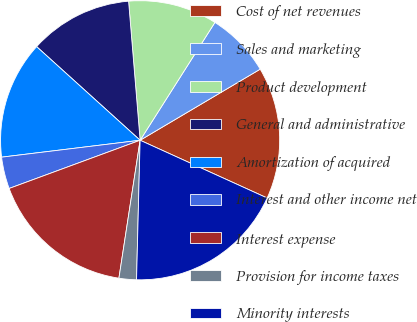Convert chart to OTSL. <chart><loc_0><loc_0><loc_500><loc_500><pie_chart><fcel>Cost of net revenues<fcel>Sales and marketing<fcel>Product development<fcel>General and administrative<fcel>Amortization of acquired<fcel>Interest and other income net<fcel>Interest expense<fcel>Provision for income taxes<fcel>Minority interests<nl><fcel>15.3%<fcel>7.49%<fcel>10.32%<fcel>11.98%<fcel>13.64%<fcel>3.68%<fcel>16.96%<fcel>2.02%<fcel>18.62%<nl></chart> 